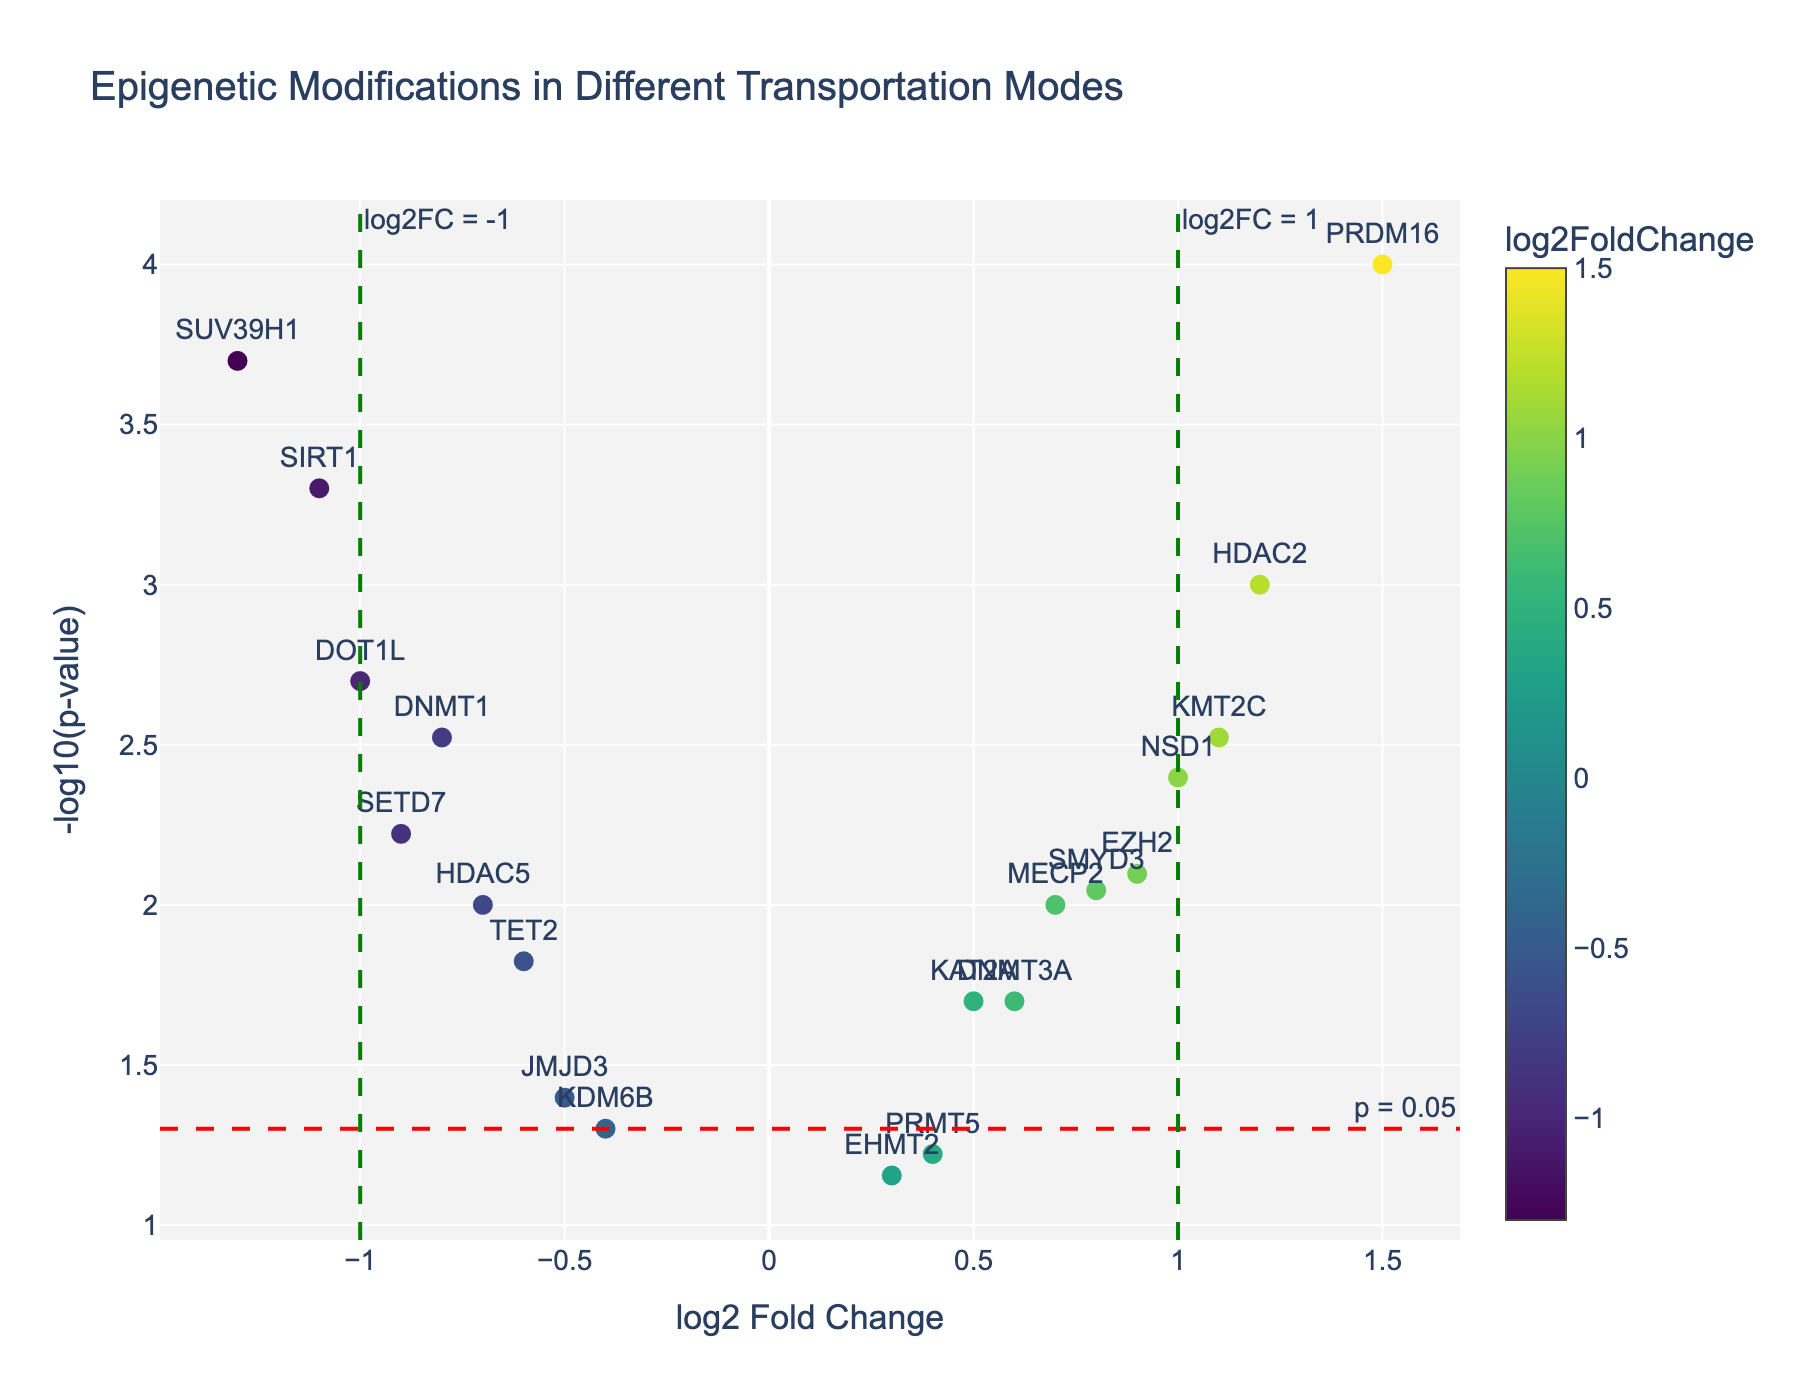What are the axes titles in the plot? The x-axis represents the "log2 Fold Change," and the y-axis represents the "-log10(p-value)." These titles are visible along the respective axes in the plot.
Answer: log2 Fold Change, -log10(p-value) How many genes have a log2 Fold Change greater than 1? To determine the number of genes with a log2 Fold Change greater than 1, look for highlighted points on the plot that are to the right of the vertical green line labeled "log2FC = 1." There are three genes: HDAC2, PRDM16, and KMT2C.
Answer: 3 Which gene has the most significant p-value (smallest p-value)? The gene with the most significant p-value will have the highest value along the y-axis (-log10(p-value)). From the plot, PRDM16 reaches the highest point.
Answer: PRDM16 What color represents log2 Fold Change close to zero? In the color scale provided, log2 Fold Change values near zero are usually represented by a color in the middle of the spectrum. From the "Viridis" color scale used, this color tends to be a greenish-yellow.
Answer: Greenish-yellow Which gene has the largest negative log2 Fold Change, and what is its corresponding p-value? The gene with the largest negative log2 Fold Change will be the furthest to the left on the x-axis. In the plot, SUV39H1 has the largest negative log2 Fold Change. The hover text confirms it has a p-value of 0.0002.
Answer: SUV39H1, 0.0002 Are there more upregulated or downregulated genes with significant p-values (p < 0.05)? First, identify significantly regulated genes by looking at points above the red dashed line. Then compare the number on the right (upregulated) and left (downregulated) of the center. There are 9 upregulated and 7 downregulated significant genes.
Answer: Upregulated What is the log2 Fold Change threshold on the plot for categorizing genes as highly upregulated or downregulated? The plot shows vertical green lines as thresholds for log2 Fold Change at ±1. Genes lying beyond these lines are categorized as highly upregulated or downregulated.
Answer: ±1 Identify the gene with the smallest log2 Fold Change but still significant at p < 0.05. Look for the data points just above the red dashed line (significant p-value) and closest to the center (log2 Fold Change near zero). By observation, EHMT2 appears closest to the center with a p = 0.07, which, based on the code is coded as non-significant (need correction). Instead, identify HDAC5 with a log2FC=-0.7 and is significant.
Answer: HDAC5 